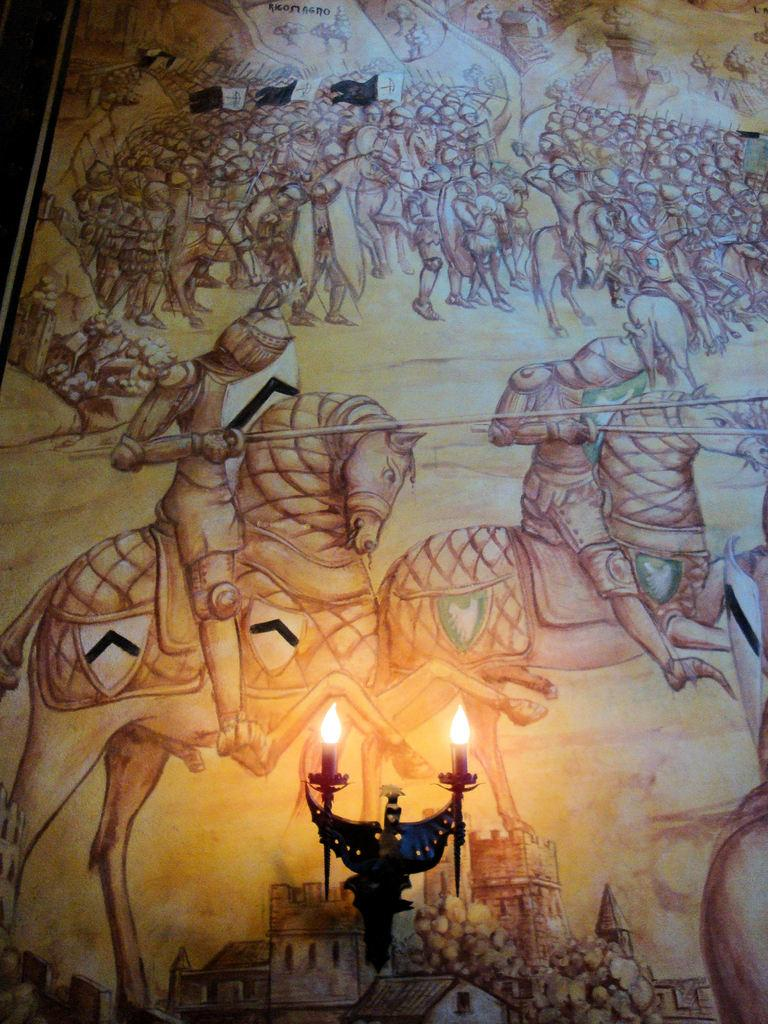What is on the wall in the image? There is a painting on the wall in the image. What is the subject of the painting? The painting depicts people riding horses. What is located at the bottom of the image? There is a stand with lights at the bottom of the image. How many veins can be seen in the painting? There are no veins visible in the painting, as it depicts people riding horses and not the human body. 